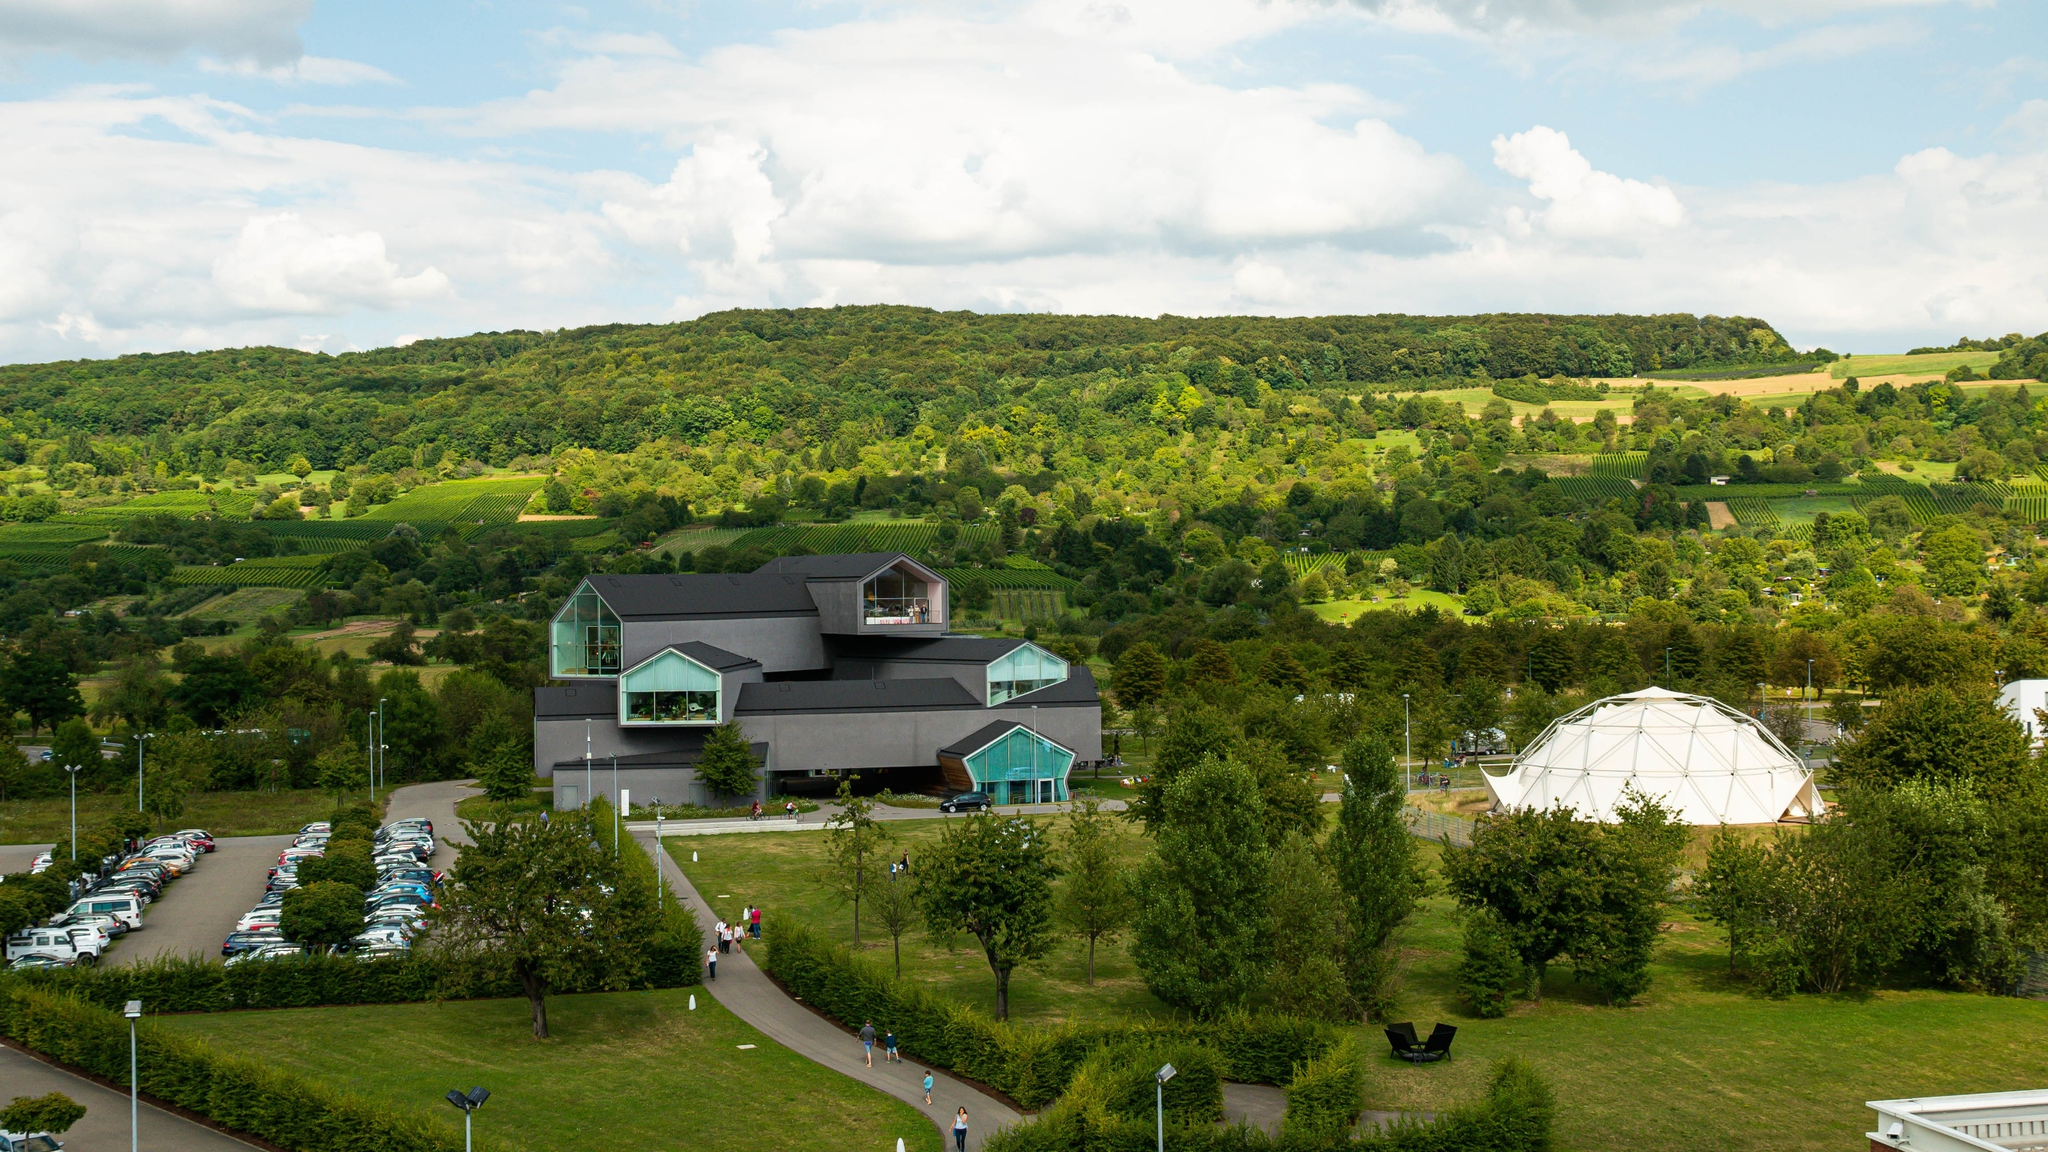Describe a quick visit to the museum. A quick visit to the Vitra Design Museum would involve a brief but memorable experience. Arriving at the easy-to-navigate parking lot, visitors would take a short walk through the picturesque surroundings to reach the museum. They could spend roughly an hour exploring the main highlights of the museum, appreciating the striking architecture and a few key exhibits. The visit might conclude with a brief stroll around the lush, green grounds, taking in the beautiful natural setting before heading back to their vehicle. 